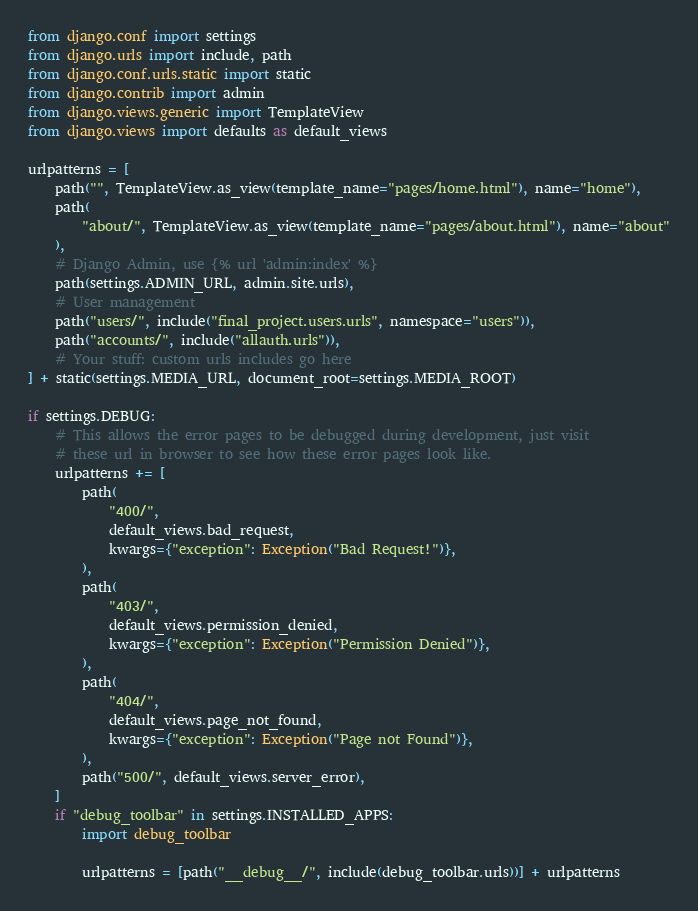<code> <loc_0><loc_0><loc_500><loc_500><_Python_>from django.conf import settings
from django.urls import include, path
from django.conf.urls.static import static
from django.contrib import admin
from django.views.generic import TemplateView
from django.views import defaults as default_views

urlpatterns = [
    path("", TemplateView.as_view(template_name="pages/home.html"), name="home"),
    path(
        "about/", TemplateView.as_view(template_name="pages/about.html"), name="about"
    ),
    # Django Admin, use {% url 'admin:index' %}
    path(settings.ADMIN_URL, admin.site.urls),
    # User management
    path("users/", include("final_project.users.urls", namespace="users")),
    path("accounts/", include("allauth.urls")),
    # Your stuff: custom urls includes go here
] + static(settings.MEDIA_URL, document_root=settings.MEDIA_ROOT)

if settings.DEBUG:
    # This allows the error pages to be debugged during development, just visit
    # these url in browser to see how these error pages look like.
    urlpatterns += [
        path(
            "400/",
            default_views.bad_request,
            kwargs={"exception": Exception("Bad Request!")},
        ),
        path(
            "403/",
            default_views.permission_denied,
            kwargs={"exception": Exception("Permission Denied")},
        ),
        path(
            "404/",
            default_views.page_not_found,
            kwargs={"exception": Exception("Page not Found")},
        ),
        path("500/", default_views.server_error),
    ]
    if "debug_toolbar" in settings.INSTALLED_APPS:
        import debug_toolbar

        urlpatterns = [path("__debug__/", include(debug_toolbar.urls))] + urlpatterns
</code> 